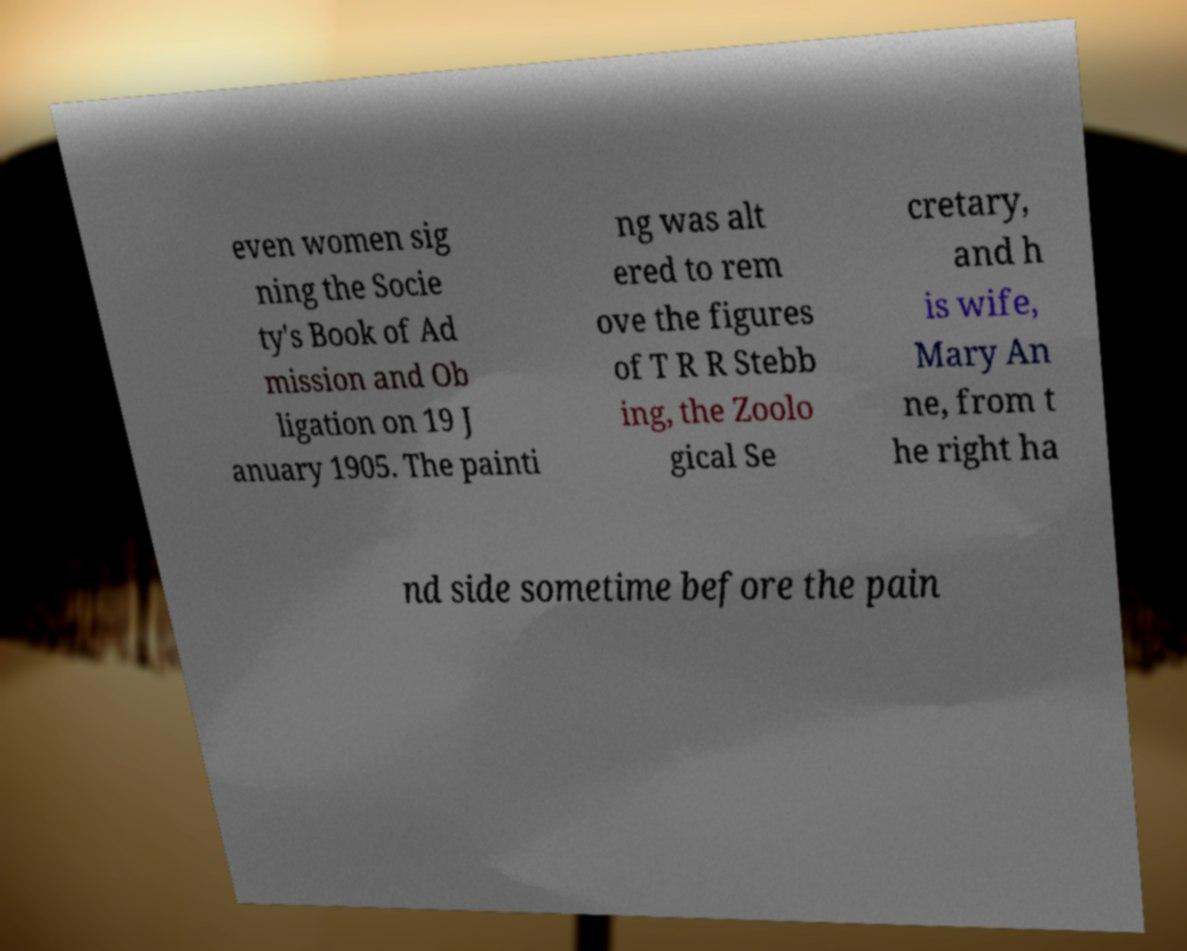I need the written content from this picture converted into text. Can you do that? even women sig ning the Socie ty's Book of Ad mission and Ob ligation on 19 J anuary 1905. The painti ng was alt ered to rem ove the figures of T R R Stebb ing, the Zoolo gical Se cretary, and h is wife, Mary An ne, from t he right ha nd side sometime before the pain 